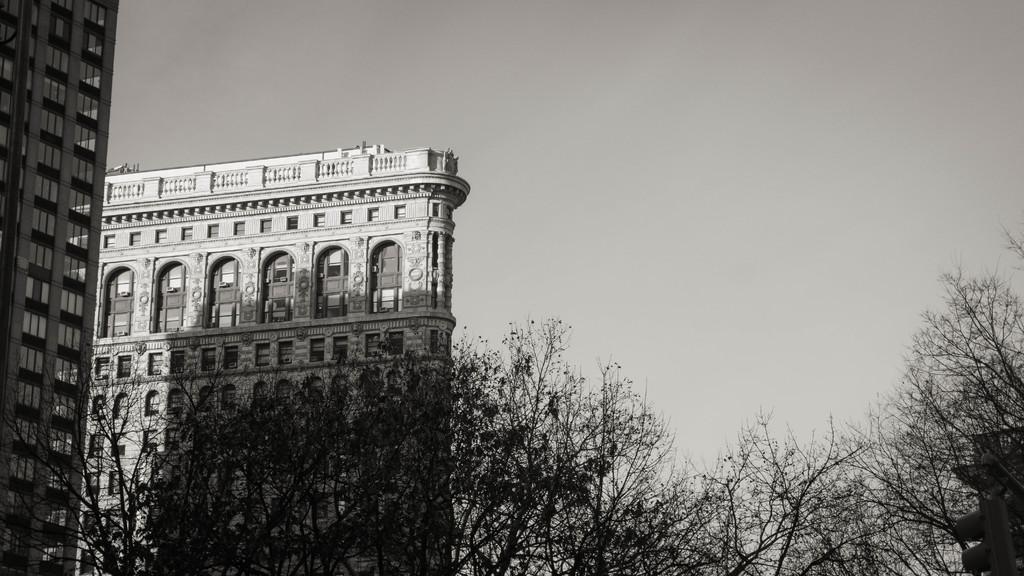Can you describe this image briefly? In this picture there are trees. We can observe large buildings in the left side. In the background there is a sky. 